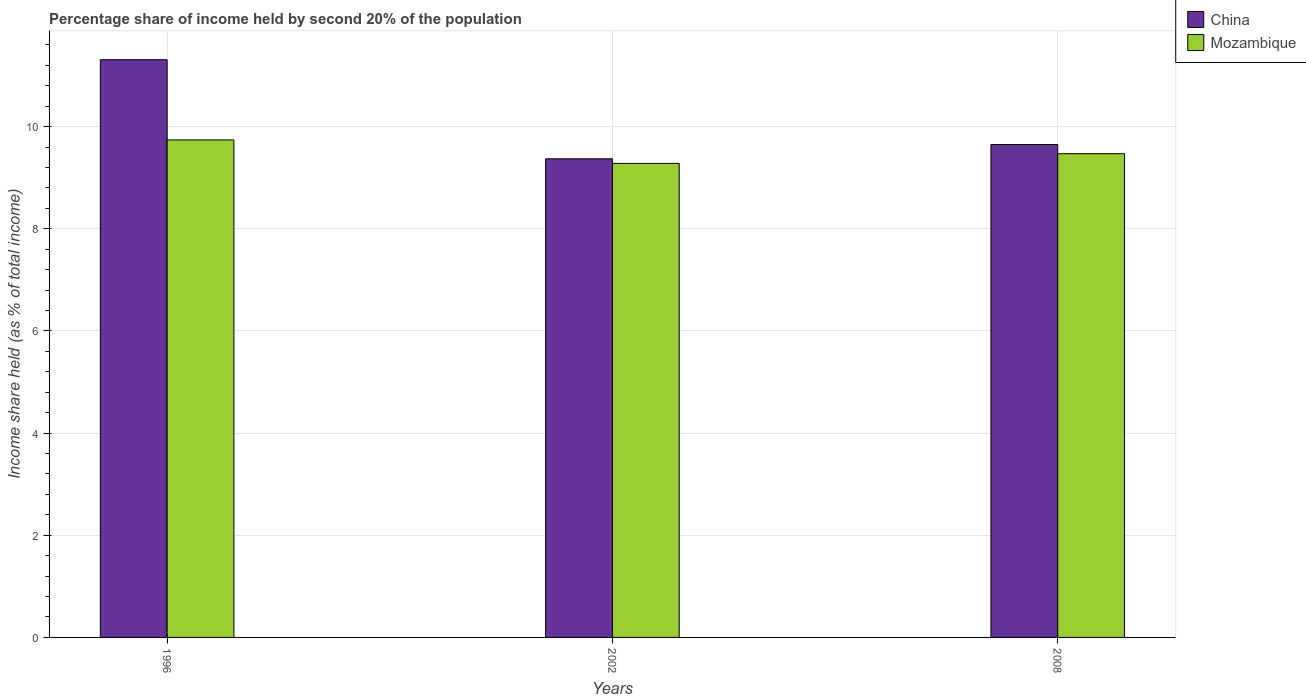How many different coloured bars are there?
Provide a succinct answer. 2. Are the number of bars per tick equal to the number of legend labels?
Provide a short and direct response. Yes. What is the label of the 2nd group of bars from the left?
Keep it short and to the point. 2002. In how many cases, is the number of bars for a given year not equal to the number of legend labels?
Offer a very short reply. 0. What is the share of income held by second 20% of the population in Mozambique in 2002?
Make the answer very short. 9.28. Across all years, what is the maximum share of income held by second 20% of the population in Mozambique?
Give a very brief answer. 9.74. Across all years, what is the minimum share of income held by second 20% of the population in China?
Offer a very short reply. 9.37. In which year was the share of income held by second 20% of the population in Mozambique maximum?
Offer a very short reply. 1996. What is the total share of income held by second 20% of the population in China in the graph?
Provide a succinct answer. 30.33. What is the difference between the share of income held by second 20% of the population in Mozambique in 2002 and that in 2008?
Your answer should be very brief. -0.19. What is the difference between the share of income held by second 20% of the population in Mozambique in 2002 and the share of income held by second 20% of the population in China in 1996?
Offer a terse response. -2.03. What is the average share of income held by second 20% of the population in Mozambique per year?
Your answer should be very brief. 9.5. In the year 1996, what is the difference between the share of income held by second 20% of the population in Mozambique and share of income held by second 20% of the population in China?
Provide a succinct answer. -1.57. What is the ratio of the share of income held by second 20% of the population in Mozambique in 2002 to that in 2008?
Ensure brevity in your answer.  0.98. What is the difference between the highest and the second highest share of income held by second 20% of the population in Mozambique?
Your answer should be very brief. 0.27. What is the difference between the highest and the lowest share of income held by second 20% of the population in Mozambique?
Offer a terse response. 0.46. In how many years, is the share of income held by second 20% of the population in China greater than the average share of income held by second 20% of the population in China taken over all years?
Provide a short and direct response. 1. Is the sum of the share of income held by second 20% of the population in China in 2002 and 2008 greater than the maximum share of income held by second 20% of the population in Mozambique across all years?
Offer a very short reply. Yes. What does the 1st bar from the right in 2002 represents?
Your response must be concise. Mozambique. What is the difference between two consecutive major ticks on the Y-axis?
Ensure brevity in your answer.  2. Are the values on the major ticks of Y-axis written in scientific E-notation?
Offer a terse response. No. Where does the legend appear in the graph?
Your answer should be compact. Top right. How are the legend labels stacked?
Your response must be concise. Vertical. What is the title of the graph?
Your answer should be very brief. Percentage share of income held by second 20% of the population. What is the label or title of the X-axis?
Make the answer very short. Years. What is the label or title of the Y-axis?
Offer a terse response. Income share held (as % of total income). What is the Income share held (as % of total income) of China in 1996?
Your response must be concise. 11.31. What is the Income share held (as % of total income) of Mozambique in 1996?
Offer a very short reply. 9.74. What is the Income share held (as % of total income) of China in 2002?
Provide a succinct answer. 9.37. What is the Income share held (as % of total income) in Mozambique in 2002?
Your response must be concise. 9.28. What is the Income share held (as % of total income) of China in 2008?
Offer a terse response. 9.65. What is the Income share held (as % of total income) of Mozambique in 2008?
Provide a short and direct response. 9.47. Across all years, what is the maximum Income share held (as % of total income) in China?
Your response must be concise. 11.31. Across all years, what is the maximum Income share held (as % of total income) in Mozambique?
Offer a very short reply. 9.74. Across all years, what is the minimum Income share held (as % of total income) of China?
Offer a very short reply. 9.37. Across all years, what is the minimum Income share held (as % of total income) of Mozambique?
Provide a short and direct response. 9.28. What is the total Income share held (as % of total income) of China in the graph?
Provide a short and direct response. 30.33. What is the total Income share held (as % of total income) in Mozambique in the graph?
Your answer should be compact. 28.49. What is the difference between the Income share held (as % of total income) in China in 1996 and that in 2002?
Give a very brief answer. 1.94. What is the difference between the Income share held (as % of total income) in Mozambique in 1996 and that in 2002?
Provide a succinct answer. 0.46. What is the difference between the Income share held (as % of total income) in China in 1996 and that in 2008?
Your answer should be very brief. 1.66. What is the difference between the Income share held (as % of total income) in Mozambique in 1996 and that in 2008?
Offer a terse response. 0.27. What is the difference between the Income share held (as % of total income) of China in 2002 and that in 2008?
Offer a very short reply. -0.28. What is the difference between the Income share held (as % of total income) in Mozambique in 2002 and that in 2008?
Offer a terse response. -0.19. What is the difference between the Income share held (as % of total income) of China in 1996 and the Income share held (as % of total income) of Mozambique in 2002?
Provide a short and direct response. 2.03. What is the difference between the Income share held (as % of total income) in China in 1996 and the Income share held (as % of total income) in Mozambique in 2008?
Your answer should be very brief. 1.84. What is the average Income share held (as % of total income) in China per year?
Make the answer very short. 10.11. What is the average Income share held (as % of total income) of Mozambique per year?
Offer a very short reply. 9.5. In the year 1996, what is the difference between the Income share held (as % of total income) in China and Income share held (as % of total income) in Mozambique?
Your answer should be compact. 1.57. In the year 2002, what is the difference between the Income share held (as % of total income) in China and Income share held (as % of total income) in Mozambique?
Your answer should be very brief. 0.09. In the year 2008, what is the difference between the Income share held (as % of total income) in China and Income share held (as % of total income) in Mozambique?
Give a very brief answer. 0.18. What is the ratio of the Income share held (as % of total income) of China in 1996 to that in 2002?
Make the answer very short. 1.21. What is the ratio of the Income share held (as % of total income) of Mozambique in 1996 to that in 2002?
Offer a terse response. 1.05. What is the ratio of the Income share held (as % of total income) of China in 1996 to that in 2008?
Provide a short and direct response. 1.17. What is the ratio of the Income share held (as % of total income) of Mozambique in 1996 to that in 2008?
Make the answer very short. 1.03. What is the ratio of the Income share held (as % of total income) of Mozambique in 2002 to that in 2008?
Offer a very short reply. 0.98. What is the difference between the highest and the second highest Income share held (as % of total income) in China?
Keep it short and to the point. 1.66. What is the difference between the highest and the second highest Income share held (as % of total income) in Mozambique?
Offer a terse response. 0.27. What is the difference between the highest and the lowest Income share held (as % of total income) of China?
Offer a terse response. 1.94. What is the difference between the highest and the lowest Income share held (as % of total income) of Mozambique?
Your answer should be compact. 0.46. 